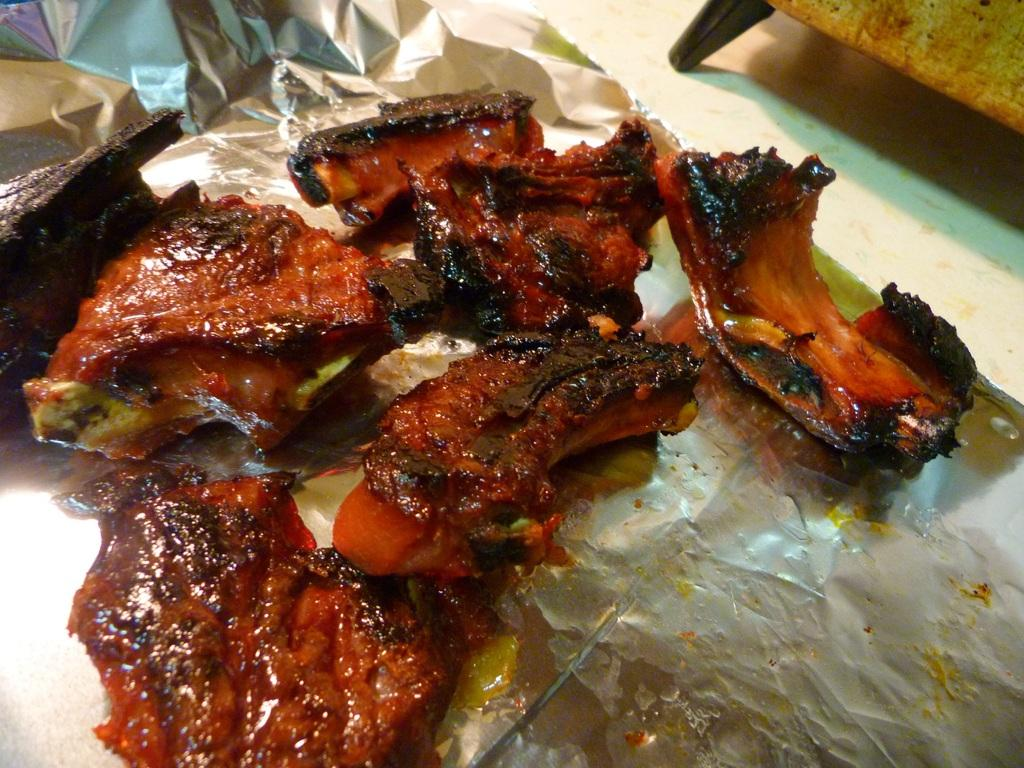What type of food can be seen in the image? There are pieces of cooked meat in the image. How are the pieces of meat arranged or placed? The meat is placed on silver foil paper. What type of material is visible in the image? There appears to be a wooden object in the image. What is visible beneath the food and wooden object? The floor is visible in the image. What type of collar can be seen on the meat in the image? There is no collar present on the meat in the image; it is simply placed on silver foil paper. What type of oatmeal is being served with the meat in the image? There is no oatmeal present in the image; it only features pieces of cooked meat and a wooden object. 